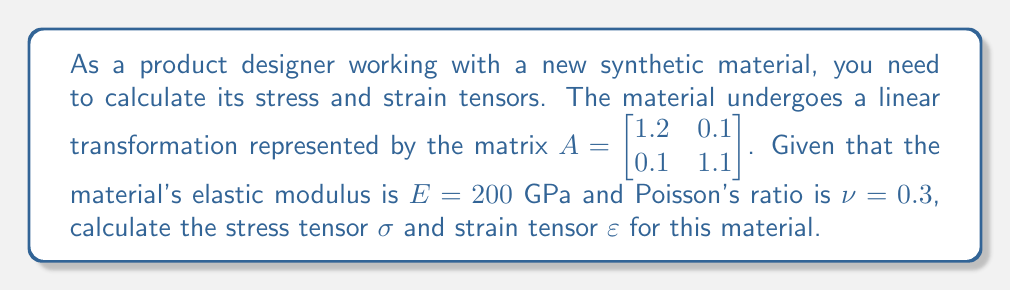Help me with this question. 1. First, we need to calculate the strain tensor $\varepsilon$. The strain tensor is derived from the deformation gradient tensor $F$, which is equal to the transformation matrix $A$:

   $F = A = \begin{bmatrix} 1.2 & 0.1 \\ 0.1 & 1.1 \end{bmatrix}$

2. The strain tensor $\varepsilon$ is calculated using the formula:

   $\varepsilon = \frac{1}{2}(F^T F - I)$

   Where $F^T$ is the transpose of $F$, and $I$ is the identity matrix.

3. Calculate $F^T F$:
   
   $F^T F = \begin{bmatrix} 1.2 & 0.1 \\ 0.1 & 1.1 \end{bmatrix} \begin{bmatrix} 1.2 & 0.1 \\ 0.1 & 1.1 \end{bmatrix} = \begin{bmatrix} 1.45 & 0.23 \\ 0.23 & 1.22 \end{bmatrix}$

4. Calculate $F^T F - I$:

   $F^T F - I = \begin{bmatrix} 1.45 & 0.23 \\ 0.23 & 1.22 \end{bmatrix} - \begin{bmatrix} 1 & 0 \\ 0 & 1 \end{bmatrix} = \begin{bmatrix} 0.45 & 0.23 \\ 0.23 & 0.22 \end{bmatrix}$

5. Calculate the strain tensor $\varepsilon$:

   $\varepsilon = \frac{1}{2}(F^T F - I) = \begin{bmatrix} 0.225 & 0.115 \\ 0.115 & 0.11 \end{bmatrix}$

6. Now, we can calculate the stress tensor $\sigma$ using Hooke's law for isotropic materials:

   $\sigma = 2\mu\varepsilon + \lambda\text{tr}(\varepsilon)I$

   Where $\mu$ and $\lambda$ are Lamé parameters, and $\text{tr}(\varepsilon)$ is the trace of $\varepsilon$.

7. Calculate Lamé parameters:

   $\mu = \frac{E}{2(1+\nu)} = \frac{200}{2(1+0.3)} = 76.92$ GPa

   $\lambda = \frac{E\nu}{(1+\nu)(1-2\nu)} = \frac{200 \cdot 0.3}{(1+0.3)(1-2\cdot0.3)} = 115.38$ GPa

8. Calculate $\text{tr}(\varepsilon)$:

   $\text{tr}(\varepsilon) = 0.225 + 0.11 = 0.335$

9. Calculate the stress tensor $\sigma$:

   $\sigma = 2(76.92)\begin{bmatrix} 0.225 & 0.115 \\ 0.115 & 0.11 \end{bmatrix} + 115.38(0.335)\begin{bmatrix} 1 & 0 \\ 0 & 1 \end{bmatrix}$

   $\sigma = \begin{bmatrix} 34.614 & 17.692 \\ 17.692 & 16.923 \end{bmatrix} + \begin{bmatrix} 38.652 & 0 \\ 0 & 38.652 \end{bmatrix}$

   $\sigma = \begin{bmatrix} 73.266 & 17.692 \\ 17.692 & 55.575 \end{bmatrix}$ GPa
Answer: $\varepsilon = \begin{bmatrix} 0.225 & 0.115 \\ 0.115 & 0.11 \end{bmatrix}$, $\sigma = \begin{bmatrix} 73.266 & 17.692 \\ 17.692 & 55.575 \end{bmatrix}$ GPa 